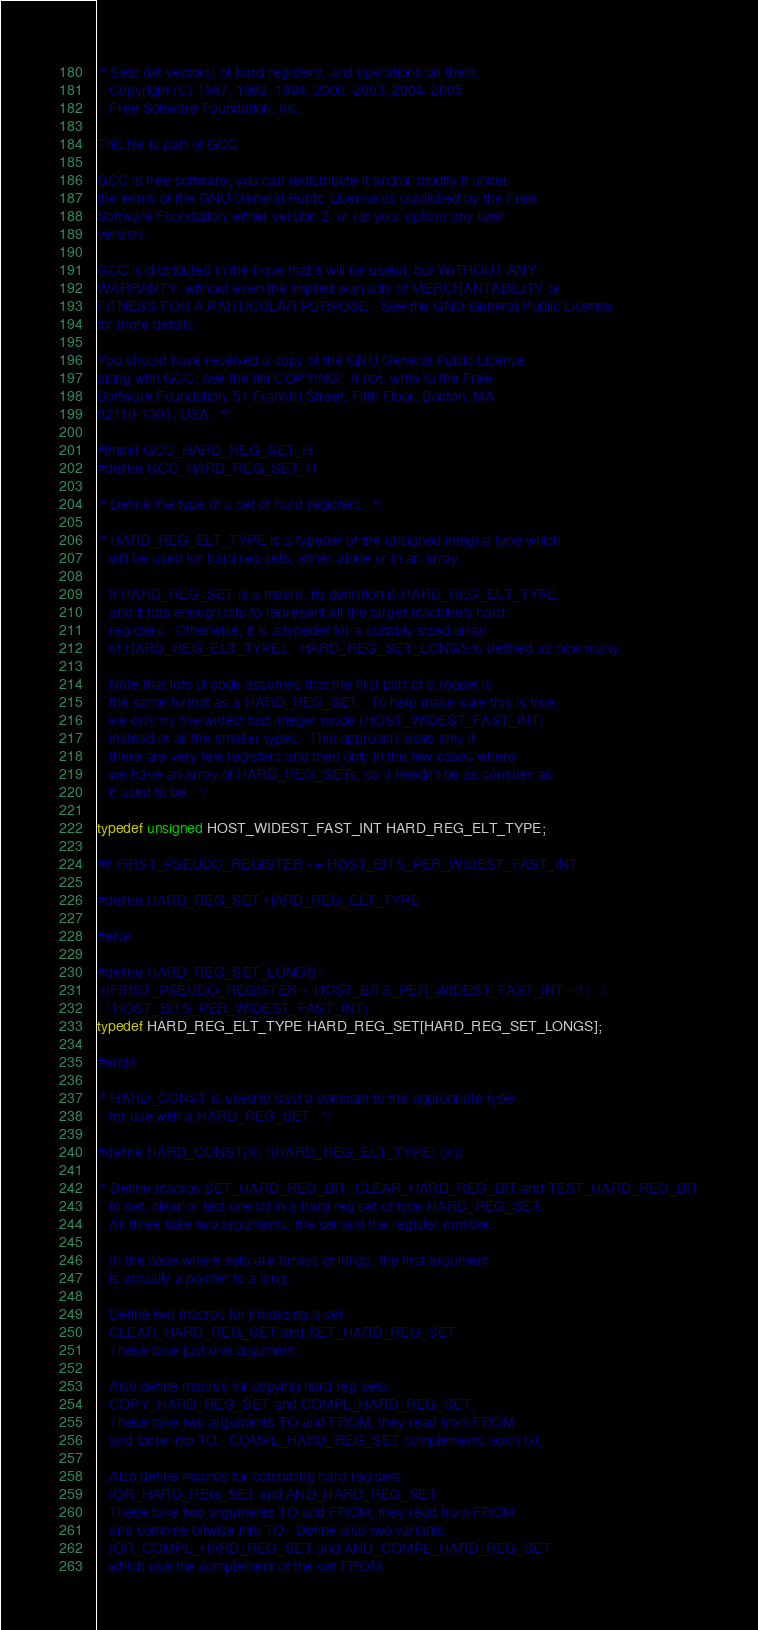<code> <loc_0><loc_0><loc_500><loc_500><_C_>/* Sets (bit vectors) of hard registers, and operations on them.
   Copyright (C) 1987, 1992, 1994, 2000, 2003, 2004, 2005
   Free Software Foundation, Inc.

This file is part of GCC

GCC is free software; you can redistribute it and/or modify it under
the terms of the GNU General Public License as published by the Free
Software Foundation; either version 2, or (at your option) any later
version.

GCC is distributed in the hope that it will be useful, but WITHOUT ANY
WARRANTY; without even the implied warranty of MERCHANTABILITY or
FITNESS FOR A PARTICULAR PURPOSE.  See the GNU General Public License
for more details.

You should have received a copy of the GNU General Public License
along with GCC; see the file COPYING.  If not, write to the Free
Software Foundation, 51 Franklin Street, Fifth Floor, Boston, MA
02110-1301, USA.  */

#ifndef GCC_HARD_REG_SET_H
#define GCC_HARD_REG_SET_H 

/* Define the type of a set of hard registers.  */

/* HARD_REG_ELT_TYPE is a typedef of the unsigned integral type which
   will be used for hard reg sets, either alone or in an array.

   If HARD_REG_SET is a macro, its definition is HARD_REG_ELT_TYPE,
   and it has enough bits to represent all the target machine's hard
   registers.  Otherwise, it is a typedef for a suitably sized array
   of HARD_REG_ELT_TYPEs.  HARD_REG_SET_LONGS is defined as how many.

   Note that lots of code assumes that the first part of a regset is
   the same format as a HARD_REG_SET.  To help make sure this is true,
   we only try the widest fast integer mode (HOST_WIDEST_FAST_INT)
   instead of all the smaller types.  This approach loses only if
   there are very few registers and then only in the few cases where
   we have an array of HARD_REG_SETs, so it needn't be as complex as
   it used to be.  */

typedef unsigned HOST_WIDEST_FAST_INT HARD_REG_ELT_TYPE;

#if FIRST_PSEUDO_REGISTER <= HOST_BITS_PER_WIDEST_FAST_INT

#define HARD_REG_SET HARD_REG_ELT_TYPE

#else

#define HARD_REG_SET_LONGS \
 ((FIRST_PSEUDO_REGISTER + HOST_BITS_PER_WIDEST_FAST_INT - 1)	\
  / HOST_BITS_PER_WIDEST_FAST_INT)
typedef HARD_REG_ELT_TYPE HARD_REG_SET[HARD_REG_SET_LONGS];

#endif

/* HARD_CONST is used to cast a constant to the appropriate type
   for use with a HARD_REG_SET.  */

#define HARD_CONST(X) ((HARD_REG_ELT_TYPE) (X))

/* Define macros SET_HARD_REG_BIT, CLEAR_HARD_REG_BIT and TEST_HARD_REG_BIT
   to set, clear or test one bit in a hard reg set of type HARD_REG_SET.
   All three take two arguments: the set and the register number.

   In the case where sets are arrays of longs, the first argument
   is actually a pointer to a long.

   Define two macros for initializing a set:
   CLEAR_HARD_REG_SET and SET_HARD_REG_SET.
   These take just one argument.

   Also define macros for copying hard reg sets:
   COPY_HARD_REG_SET and COMPL_HARD_REG_SET.
   These take two arguments TO and FROM; they read from FROM
   and store into TO.  COMPL_HARD_REG_SET complements each bit.

   Also define macros for combining hard reg sets:
   IOR_HARD_REG_SET and AND_HARD_REG_SET.
   These take two arguments TO and FROM; they read from FROM
   and combine bitwise into TO.  Define also two variants
   IOR_COMPL_HARD_REG_SET and AND_COMPL_HARD_REG_SET
   which use the complement of the set FROM.
</code> 